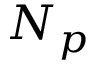Convert formula to latex. <formula><loc_0><loc_0><loc_500><loc_500>N _ { p }</formula> 